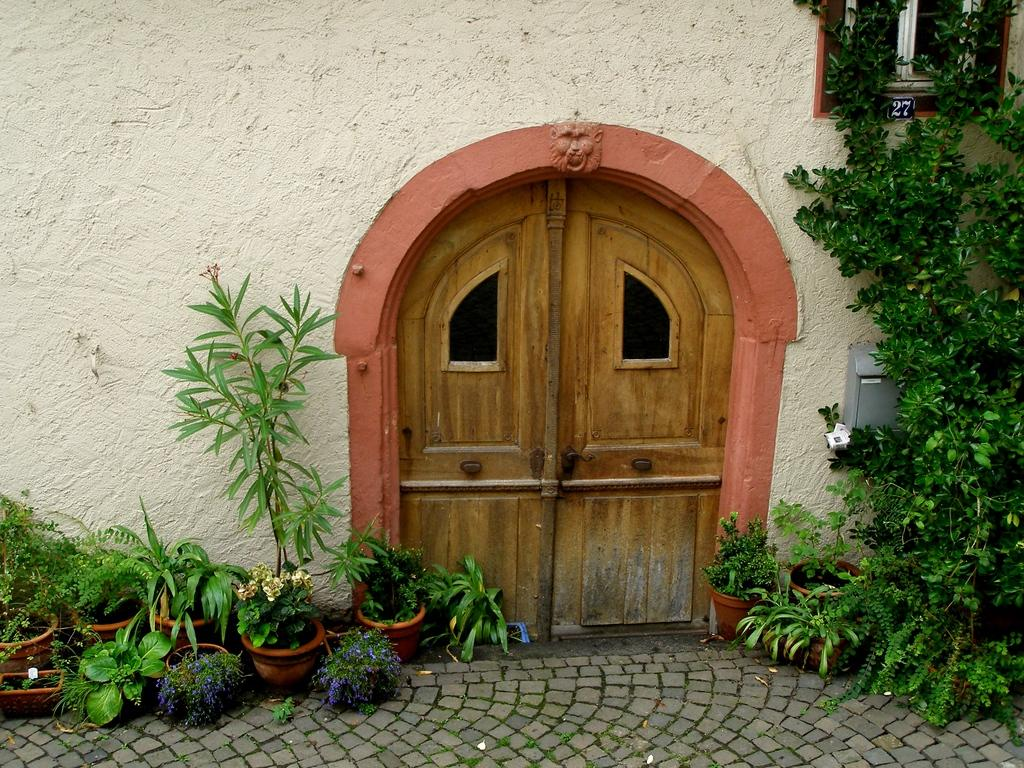What type of door is shown in the image? There is a small wooden door in the image. Are there any plants or flowers near the door? Yes, there are flower pots with purple and white color flowers near the door, and a plant visible to the right of the door. How many cows can be seen saying good-bye near the door in the image? There are no cows or any indication of good-bye in the image. 